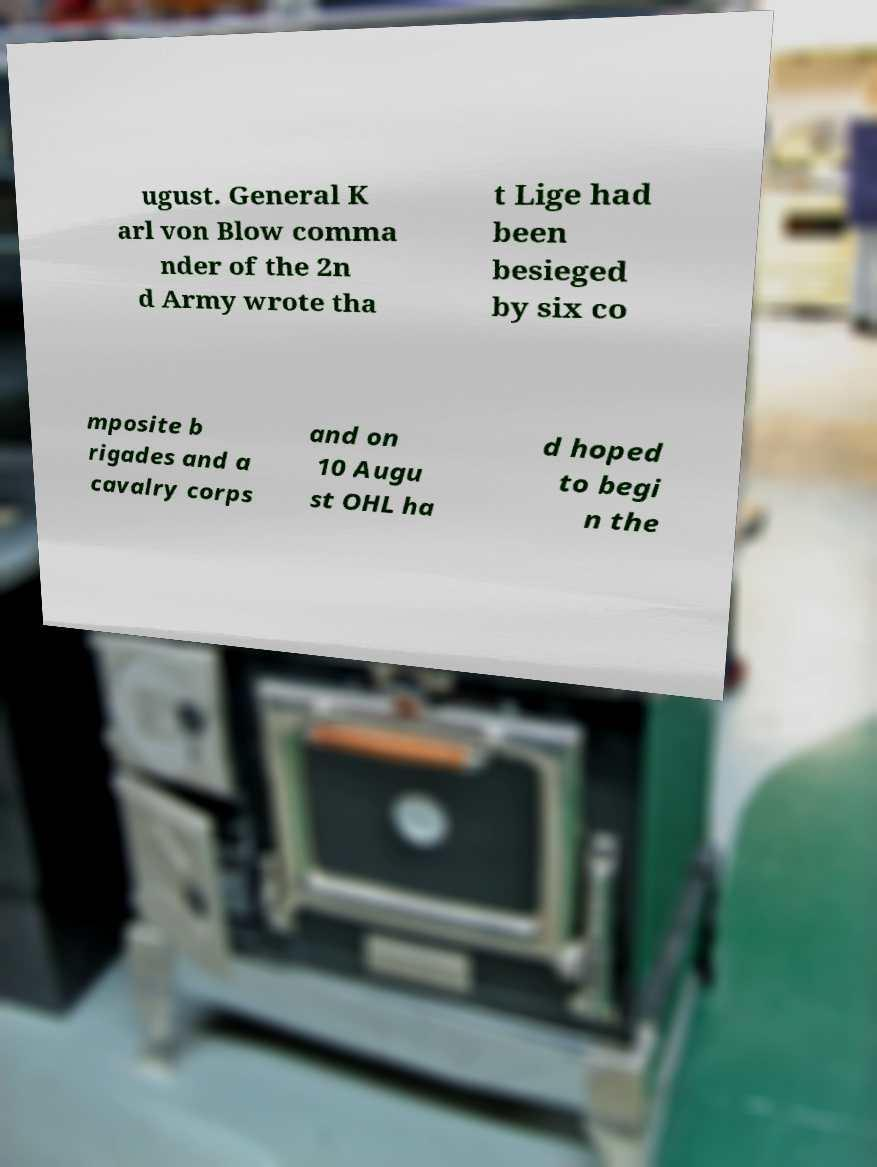Please identify and transcribe the text found in this image. ugust. General K arl von Blow comma nder of the 2n d Army wrote tha t Lige had been besieged by six co mposite b rigades and a cavalry corps and on 10 Augu st OHL ha d hoped to begi n the 